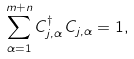<formula> <loc_0><loc_0><loc_500><loc_500>\sum _ { \alpha = 1 } ^ { m + n } C _ { j , \alpha } ^ { \dagger } \, C _ { j , \alpha } = 1 ,</formula> 